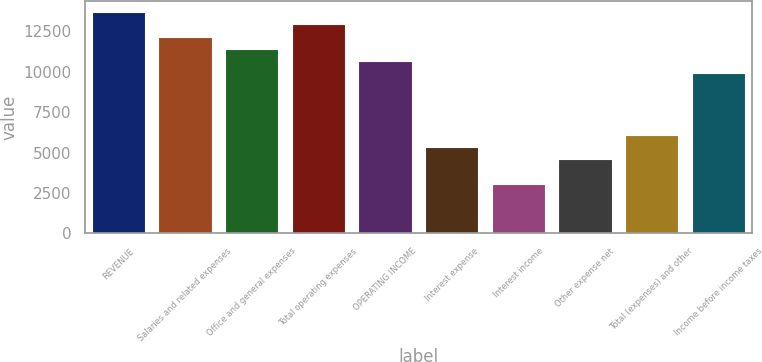Convert chart. <chart><loc_0><loc_0><loc_500><loc_500><bar_chart><fcel>REVENUE<fcel>Salaries and related expenses<fcel>Office and general expenses<fcel>Total operating expenses<fcel>OPERATING INCOME<fcel>Interest expense<fcel>Interest income<fcel>Other expense net<fcel>Total (expenses) and other<fcel>Income before income taxes<nl><fcel>13704.4<fcel>12181.8<fcel>11420.4<fcel>12943.1<fcel>10659.1<fcel>5329.79<fcel>3045.8<fcel>4568.46<fcel>6091.12<fcel>9897.77<nl></chart> 